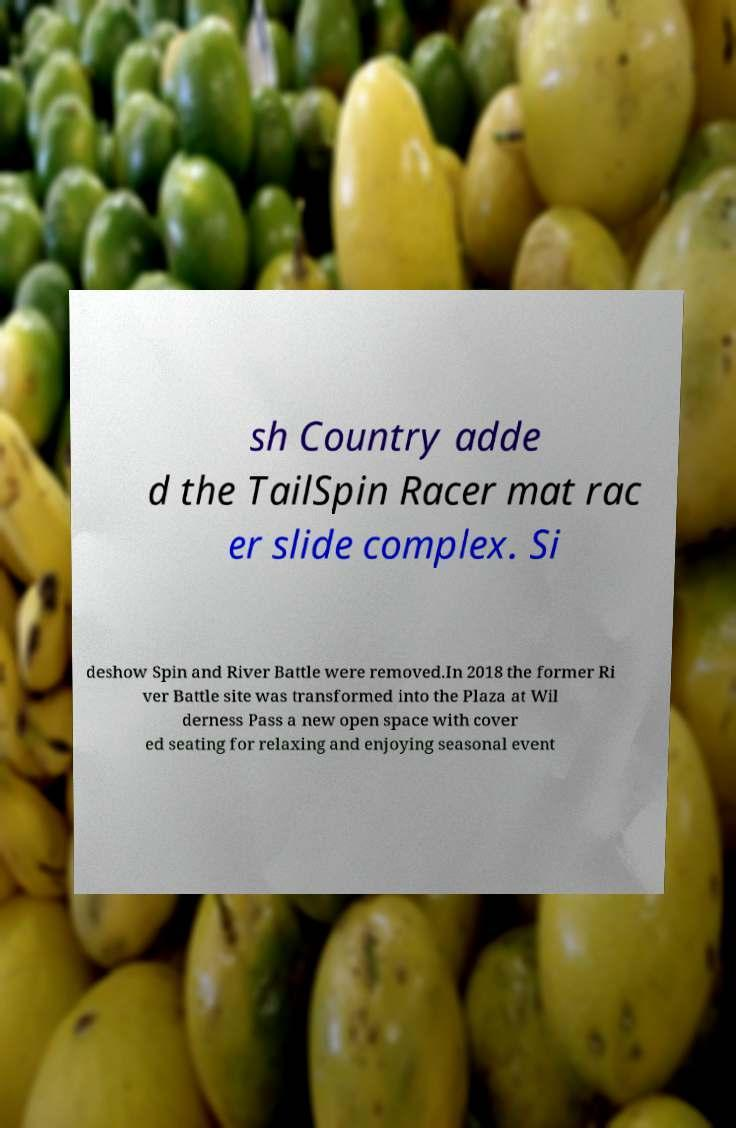Can you accurately transcribe the text from the provided image for me? sh Country adde d the TailSpin Racer mat rac er slide complex. Si deshow Spin and River Battle were removed.In 2018 the former Ri ver Battle site was transformed into the Plaza at Wil derness Pass a new open space with cover ed seating for relaxing and enjoying seasonal event 